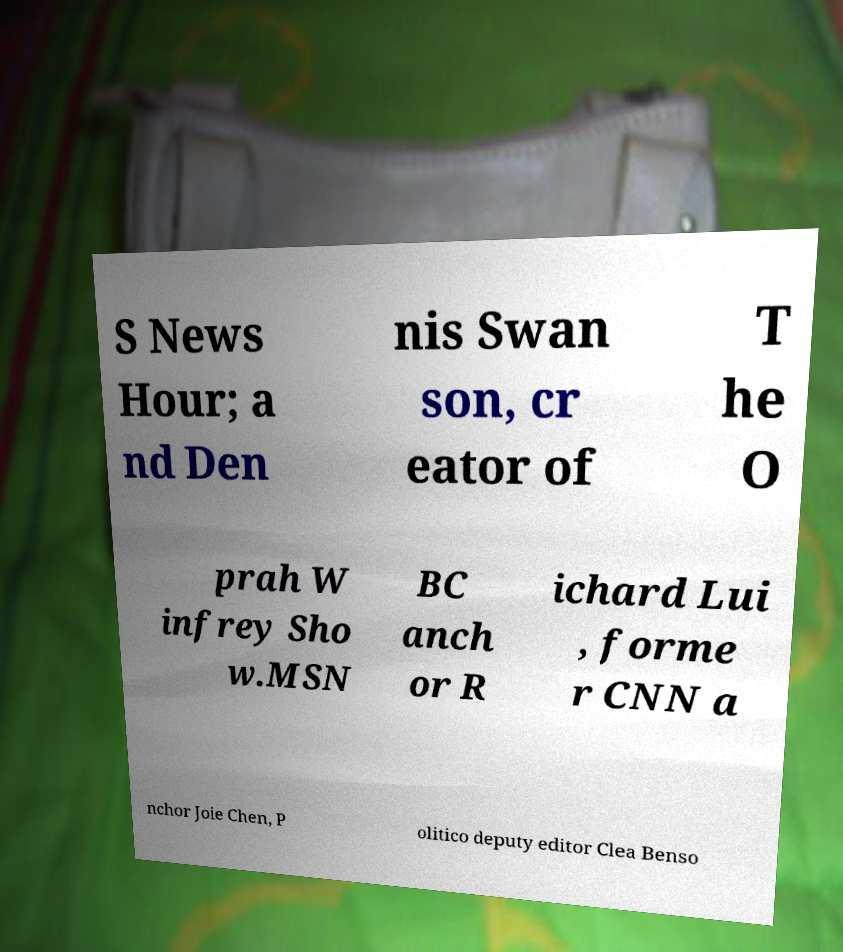What messages or text are displayed in this image? I need them in a readable, typed format. S News Hour; a nd Den nis Swan son, cr eator of T he O prah W infrey Sho w.MSN BC anch or R ichard Lui , forme r CNN a nchor Joie Chen, P olitico deputy editor Clea Benso 